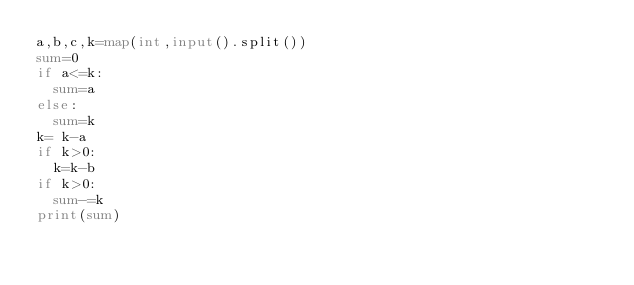Convert code to text. <code><loc_0><loc_0><loc_500><loc_500><_Python_>a,b,c,k=map(int,input().split())
sum=0
if a<=k:
	sum=a
else:
	sum=k
k= k-a
if k>0:
	k=k-b
if k>0:
	sum-=k
print(sum)
</code> 